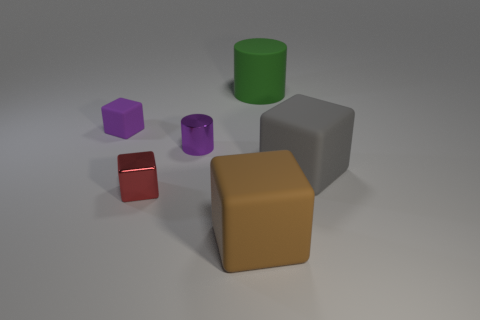Is the material of the purple object to the left of the purple metallic thing the same as the large block that is behind the tiny red cube? The materials appear similar in terms of rendering properties, both exhibiting a matte finish with no discernible texture differences. However, without additional context such as material identifiers or touch and feel, one cannot determine with absolute certainty if the materials are identical. Based on visual assessment alone, it can be said that there is a high likelihood that the material of the purple object on the left and the large gray block behind the small red cube are the same or very similar. 